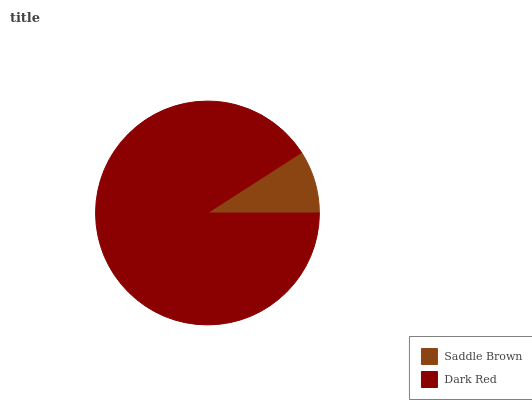Is Saddle Brown the minimum?
Answer yes or no. Yes. Is Dark Red the maximum?
Answer yes or no. Yes. Is Dark Red the minimum?
Answer yes or no. No. Is Dark Red greater than Saddle Brown?
Answer yes or no. Yes. Is Saddle Brown less than Dark Red?
Answer yes or no. Yes. Is Saddle Brown greater than Dark Red?
Answer yes or no. No. Is Dark Red less than Saddle Brown?
Answer yes or no. No. Is Dark Red the high median?
Answer yes or no. Yes. Is Saddle Brown the low median?
Answer yes or no. Yes. Is Saddle Brown the high median?
Answer yes or no. No. Is Dark Red the low median?
Answer yes or no. No. 